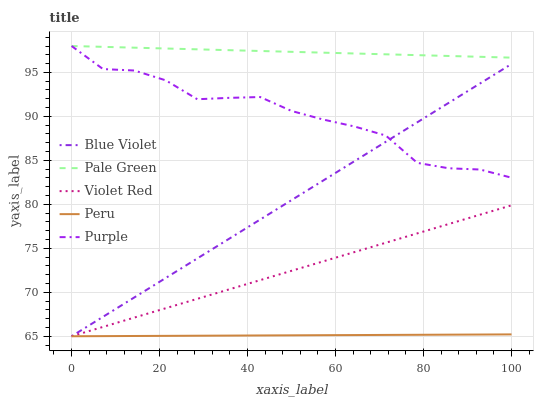Does Peru have the minimum area under the curve?
Answer yes or no. Yes. Does Pale Green have the maximum area under the curve?
Answer yes or no. Yes. Does Violet Red have the minimum area under the curve?
Answer yes or no. No. Does Violet Red have the maximum area under the curve?
Answer yes or no. No. Is Violet Red the smoothest?
Answer yes or no. Yes. Is Purple the roughest?
Answer yes or no. Yes. Is Pale Green the smoothest?
Answer yes or no. No. Is Pale Green the roughest?
Answer yes or no. No. Does Pale Green have the lowest value?
Answer yes or no. No. Does Pale Green have the highest value?
Answer yes or no. Yes. Does Violet Red have the highest value?
Answer yes or no. No. Is Violet Red less than Purple?
Answer yes or no. Yes. Is Pale Green greater than Blue Violet?
Answer yes or no. Yes. Does Violet Red intersect Purple?
Answer yes or no. No. 